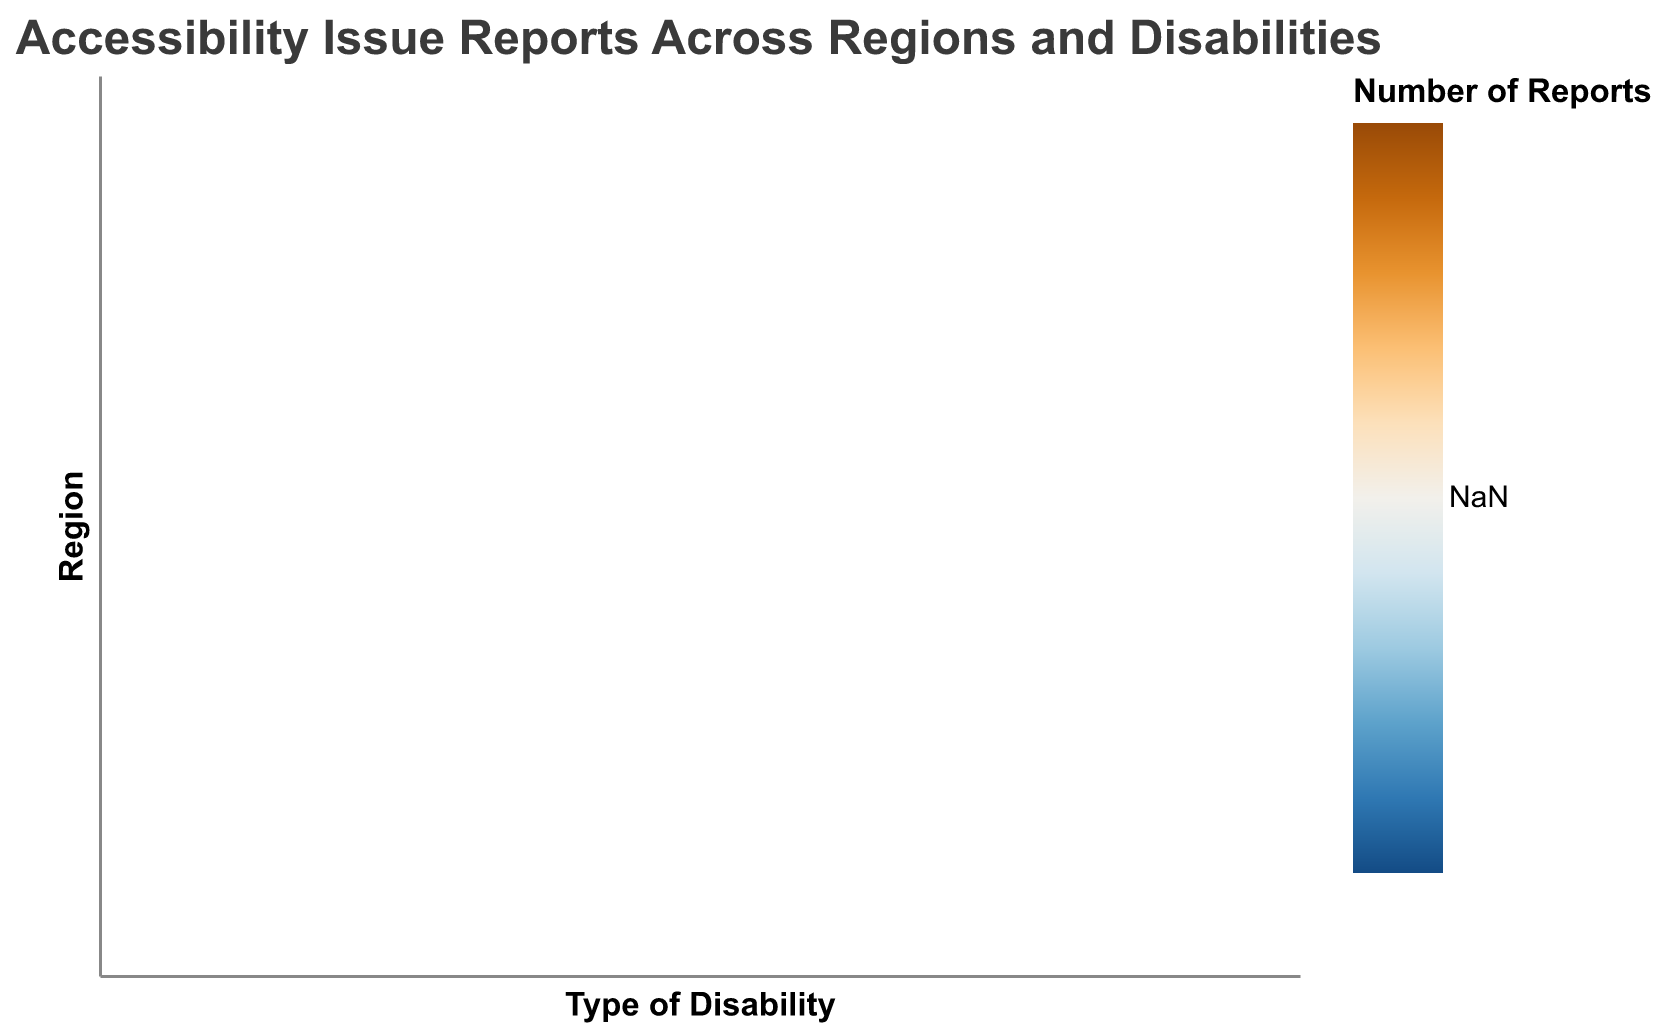What region has the highest number of reports for Mobility Challenges? Look at the row corresponding to Mobility Challenges and find the region with the darkest color. North America has 200 reports for Mobility Challenges, which is the highest.
Answer: North America Which type of disability has the fewest reports in Antarctica? In the Antarctica row, find the cell with the lightest color. The number of reports for Hearing Impairment is 3, which is the fewest.
Answer: Hearing Impairment How many more reports are there for Visual Impairment in Europe compared to Africa? Subtract the number of reports in Africa (60) from the number of reports in Europe (140): 140 - 60 = 80
Answer: 80 Which region has the most balanced number of reports across all disability types? Examine the rows to identify the one where the colors are most similar, indicating similar values. Asia's row has relatively balanced colors, meaning the values for different disabilities are close to each other.
Answer: Asia Rank the regions by the total number of reports across all disabilities from highest to lowest. Add up the values for all disability types in each region:  
North America: 120+90+200+150 = 560  
South America: 80+60+150+110 = 400  
Europe: 140+100+220+180 = 640  
Africa: 60+40+80+70 = 250  
Asia: 110+70+180+140 = 500  
Australia: 50+30+100+90 = 270  
Antarctica: 5+3+8+4 = 20  
Rank: Europe > North America > Asia > South America > Australia > Africa > Antarctica
Answer: Europe, North America, Asia, South America, Australia, Africa, Antarctica Which type of disability has the highest number of total reports across all regions and what is the sum? Sum the number of reports for each type of disability across all regions:  
Visual Impairment: 120+80+140+60+110+50+5 = 565  
Hearing Impairment: 90+60+100+40+70+30+3 = 393  
Mobility Challenges: 200+150+220+80+180+100+8 = 938  
Cognitive Disabilities: 150+110+180+70+140+90+4 = 744  
The highest sum is for Mobility Challenges, which is 938.
Answer: Mobility Challenges, 938 What is the average number of reports for Cognitive Disabilities in all regions? To find the average, sum the number of reports for Cognitive Disabilities and divide by the number of regions:  
(150+110+180+70+140+90+4) / 7 ≈ 107.71
Answer: ~107.71 Which region has the least number of total reports, and how many are there? Sum the total reports for each region and identify the smallest sum:  
North America: 560  
South America: 400  
Europe: 640  
Africa: 250  
Asia: 500  
Australia: 270  
Antarctica: 20  
The smallest sum is for Antarctica with 20 reports.
Answer: Antarctica, 20 